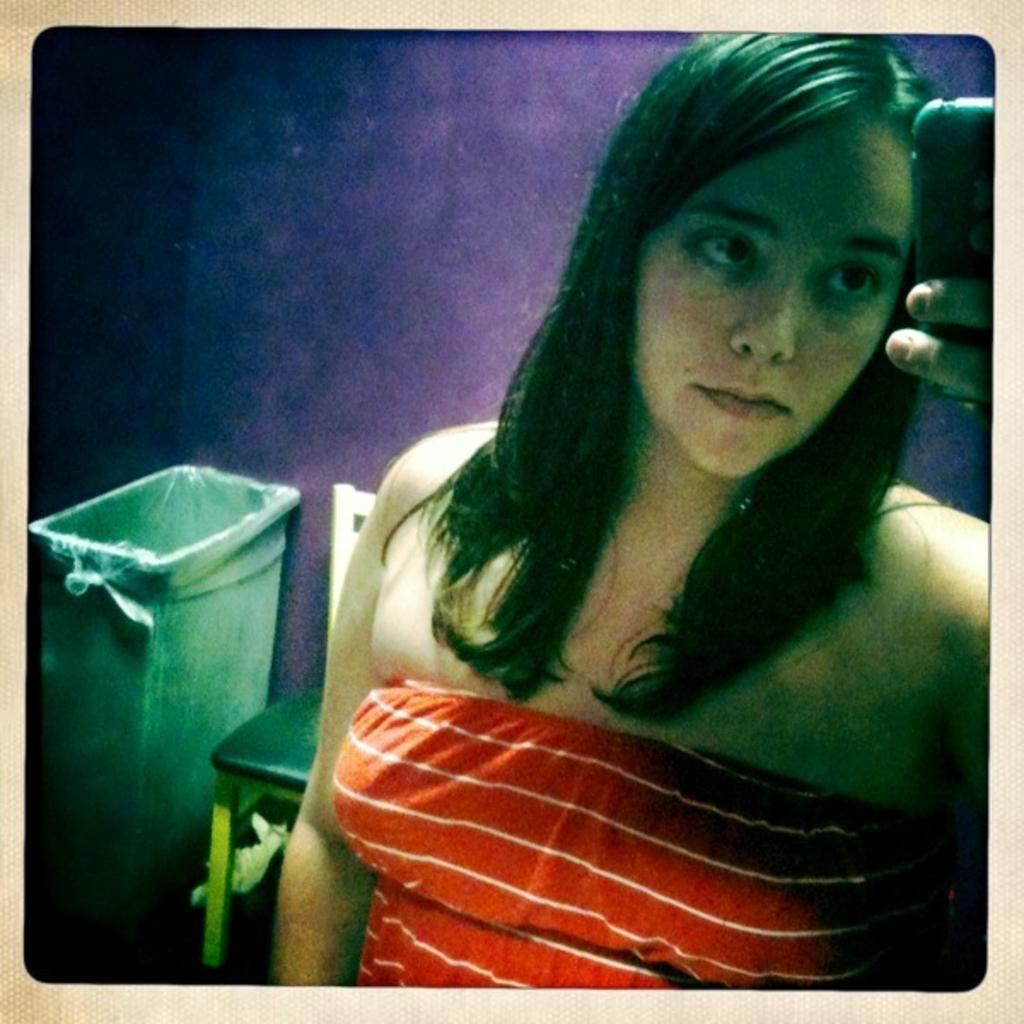In one or two sentences, can you explain what this image depicts? In the image we can see a photo. In the photo a woman is standing and holding a mobile phone. Behind her we can see a chair and dustbin. Behind the dustbin we can see a wall. 